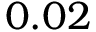Convert formula to latex. <formula><loc_0><loc_0><loc_500><loc_500>0 . 0 2</formula> 